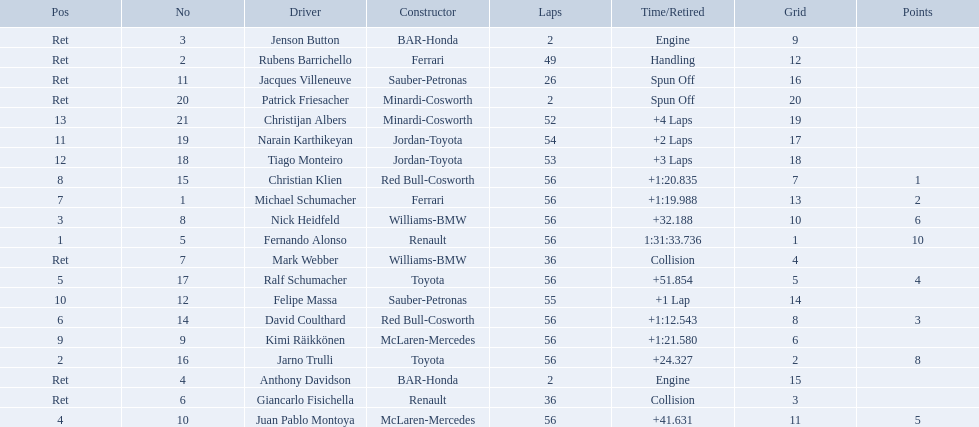Who raced during the 2005 malaysian grand prix? Fernando Alonso, Jarno Trulli, Nick Heidfeld, Juan Pablo Montoya, Ralf Schumacher, David Coulthard, Michael Schumacher, Christian Klien, Kimi Räikkönen, Felipe Massa, Narain Karthikeyan, Tiago Monteiro, Christijan Albers, Rubens Barrichello, Giancarlo Fisichella, Mark Webber, Jacques Villeneuve, Jenson Button, Anthony Davidson, Patrick Friesacher. What were their finishing times? 1:31:33.736, +24.327, +32.188, +41.631, +51.854, +1:12.543, +1:19.988, +1:20.835, +1:21.580, +1 Lap, +2 Laps, +3 Laps, +4 Laps, Handling, Collision, Collision, Spun Off, Engine, Engine, Spun Off. What was fernando alonso's finishing time? 1:31:33.736. 